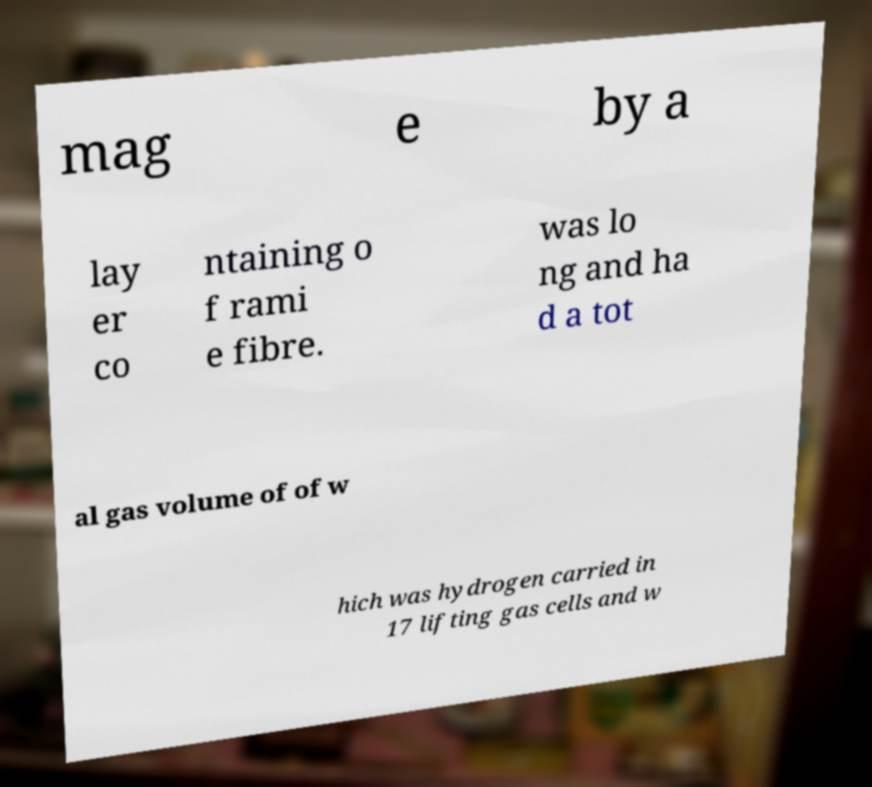Please read and relay the text visible in this image. What does it say? mag e by a lay er co ntaining o f rami e fibre. was lo ng and ha d a tot al gas volume of of w hich was hydrogen carried in 17 lifting gas cells and w 